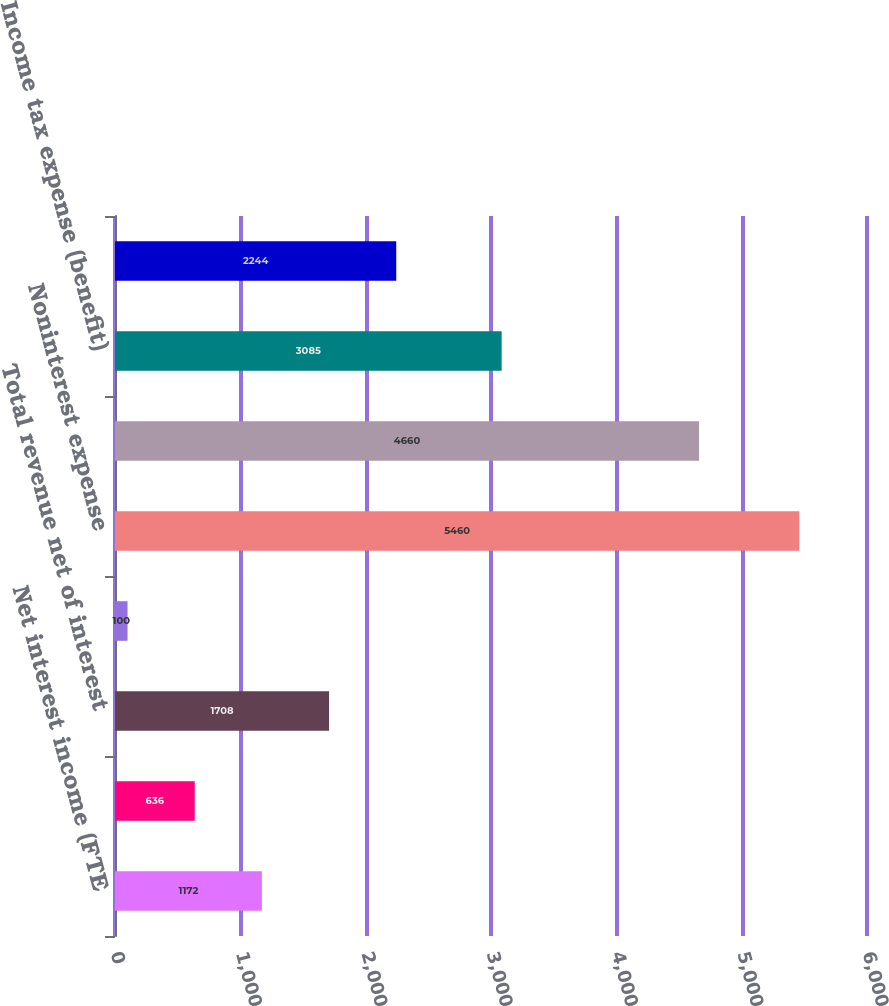Convert chart to OTSL. <chart><loc_0><loc_0><loc_500><loc_500><bar_chart><fcel>Net interest income (FTE<fcel>Noninterest income<fcel>Total revenue net of interest<fcel>Provision for credit losses<fcel>Noninterest expense<fcel>Income (loss) before income<fcel>Income tax expense (benefit)<fcel>Net income (loss)<nl><fcel>1172<fcel>636<fcel>1708<fcel>100<fcel>5460<fcel>4660<fcel>3085<fcel>2244<nl></chart> 